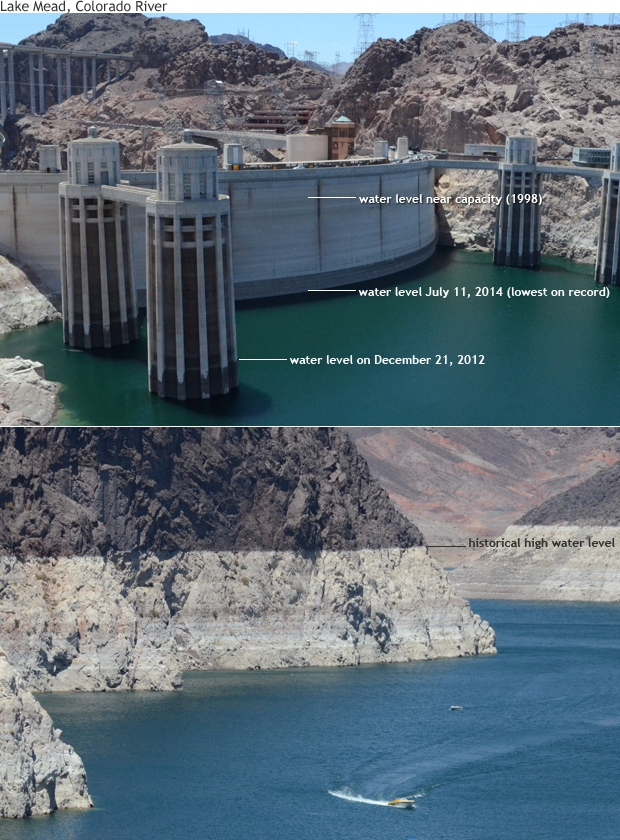Can you explain the significance of the water levels shown in the image? The image shows different water levels of Lake Mead over several years, marked by significant dates. These levels reflect the historical trends of water availability in the area. For instance, the water level near capacity in 1998 signifies a time when the reservoir was relatively full. The levels from December 21, 2012, and July 11, 2014, each indicate times of lower water levels, with 2014 marking the lowest on record. These fluctuations highlight the pressing issues of water management and the impact of droughts and human consumption on one of the largest reservoirs in the United States. How has the reduction in water levels affected the surrounding ecosystem and human populations? The reduction in water levels at Lake Mead has significant implications for both the surrounding ecosystem and human populations. For the ecosystem, lower water levels can lead to habitat loss for aquatic and riparian species, decreased water quality, and increased competition for limited water resources. On the human side, millions of people in the southwestern United States rely on Lake Mead for drinking water, agriculture, and industry. Reduced water levels can trigger water restrictions, impact agricultural productivity, and threaten the reliability of water supply to urban areas. This scenario necessitates stringent water management and conservation efforts to adapt to a changing climate and population demands. Imagining a fantastical scenario, what if the lake bed revealed a hidden ancient city? If the receding waters of Lake Mead unveiled a hidden ancient city, it would undoubtedly be one of the most exciting archaeological discoveries in modern history. The city, preserved under layers of sediment, might offer unparalleled insights into ancient civilizations that inhabited the region long before modern times. Researchers could unearth artifacts, architectural marvels, and possibly entire complexes that tell stories of past societies' culture, technology, and daily life. Such a discovery would draw global attention, sparking a wave of scientific research and possibly even changing historical narratives about human settlement and development in North America. This newfound treasure could also redefine cultural heritage and tourism in the region, infusing an element of ancient mystery into the area's modern landscape. 